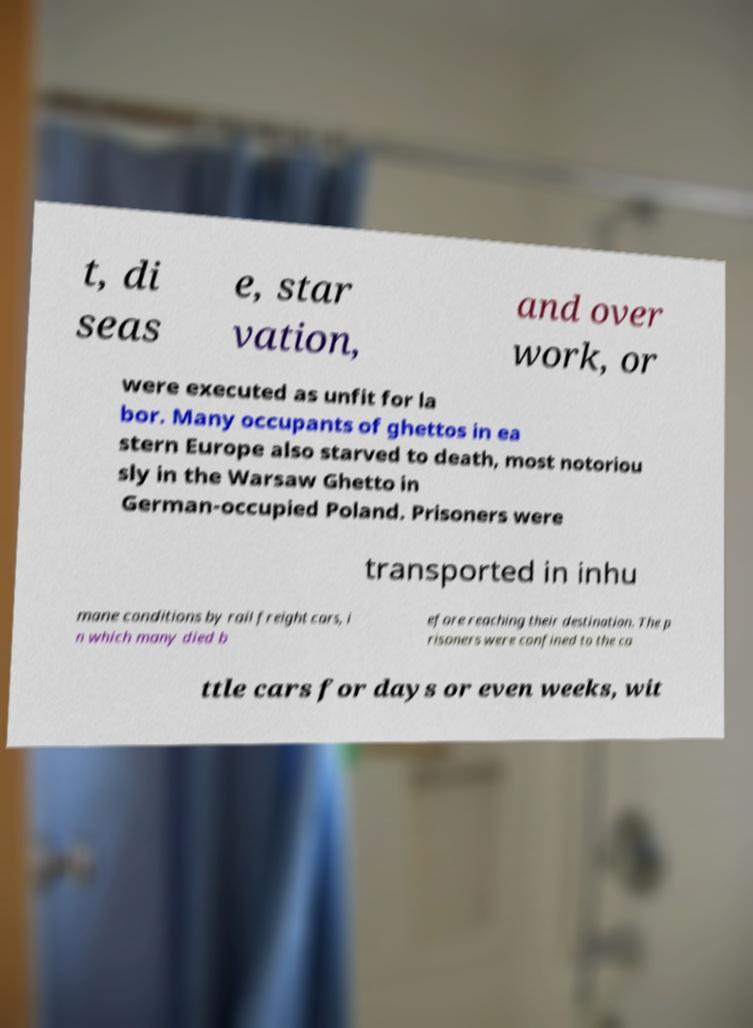For documentation purposes, I need the text within this image transcribed. Could you provide that? t, di seas e, star vation, and over work, or were executed as unfit for la bor. Many occupants of ghettos in ea stern Europe also starved to death, most notoriou sly in the Warsaw Ghetto in German-occupied Poland. Prisoners were transported in inhu mane conditions by rail freight cars, i n which many died b efore reaching their destination. The p risoners were confined to the ca ttle cars for days or even weeks, wit 